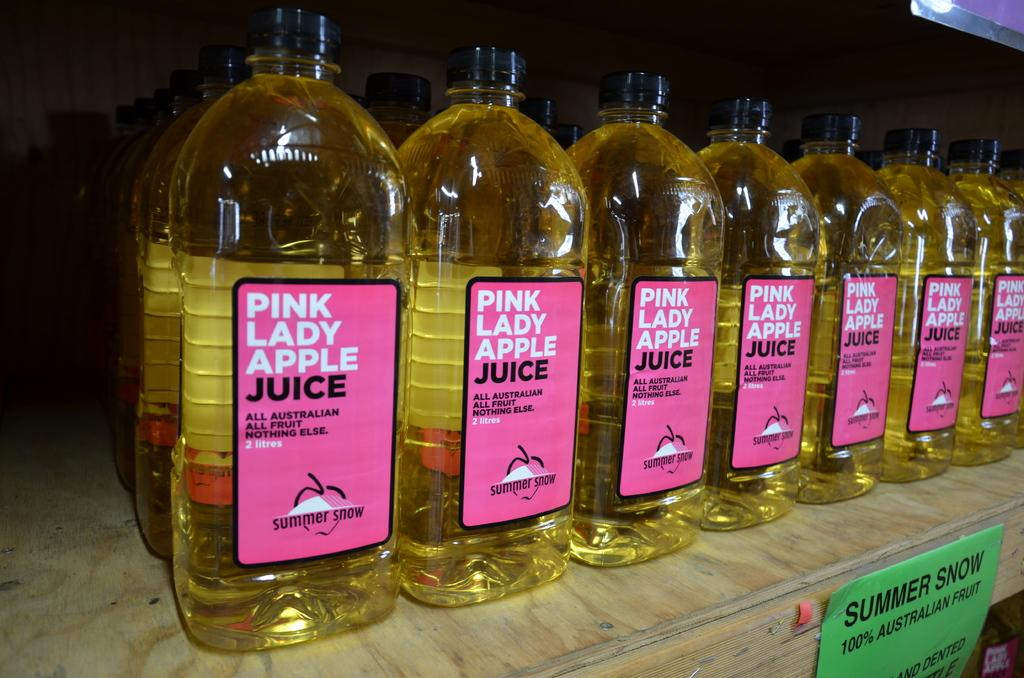Provide a one-sentence caption for the provided image. Seven bottles of Pink Lady Apple Juice standing side by side on a retail shelf. 